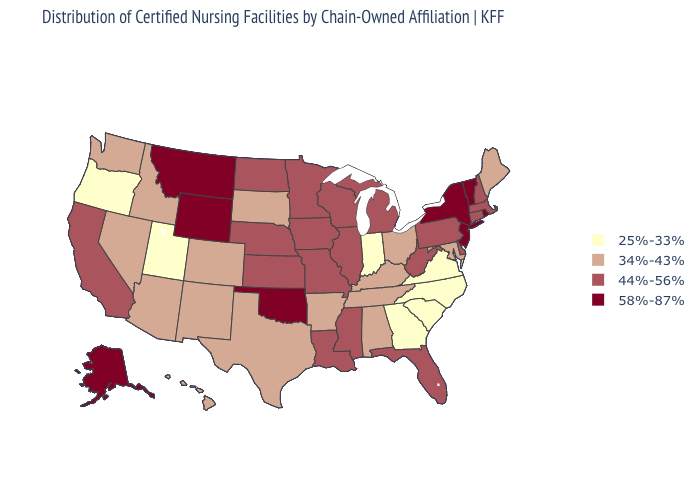Among the states that border West Virginia , does Ohio have the lowest value?
Write a very short answer. No. Among the states that border Indiana , which have the highest value?
Short answer required. Illinois, Michigan. Name the states that have a value in the range 58%-87%?
Short answer required. Alaska, Montana, New Jersey, New York, Oklahoma, Rhode Island, Vermont, Wyoming. What is the value of Hawaii?
Quick response, please. 34%-43%. Name the states that have a value in the range 44%-56%?
Short answer required. California, Connecticut, Delaware, Florida, Illinois, Iowa, Kansas, Louisiana, Massachusetts, Michigan, Minnesota, Mississippi, Missouri, Nebraska, New Hampshire, North Dakota, Pennsylvania, West Virginia, Wisconsin. What is the value of Rhode Island?
Concise answer only. 58%-87%. What is the value of New York?
Keep it brief. 58%-87%. Does New Jersey have the highest value in the Northeast?
Give a very brief answer. Yes. Which states have the lowest value in the USA?
Give a very brief answer. Georgia, Indiana, North Carolina, Oregon, South Carolina, Utah, Virginia. Name the states that have a value in the range 44%-56%?
Concise answer only. California, Connecticut, Delaware, Florida, Illinois, Iowa, Kansas, Louisiana, Massachusetts, Michigan, Minnesota, Mississippi, Missouri, Nebraska, New Hampshire, North Dakota, Pennsylvania, West Virginia, Wisconsin. Is the legend a continuous bar?
Be succinct. No. What is the highest value in the USA?
Answer briefly. 58%-87%. Name the states that have a value in the range 34%-43%?
Write a very short answer. Alabama, Arizona, Arkansas, Colorado, Hawaii, Idaho, Kentucky, Maine, Maryland, Nevada, New Mexico, Ohio, South Dakota, Tennessee, Texas, Washington. Does Alaska have the lowest value in the USA?
Write a very short answer. No. Does Oklahoma have the highest value in the South?
Keep it brief. Yes. 